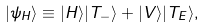<formula> <loc_0><loc_0><loc_500><loc_500>| \psi _ { H } \rangle \equiv | H \rangle | T _ { - } \rangle + | V \rangle | T _ { E } \rangle ,</formula> 